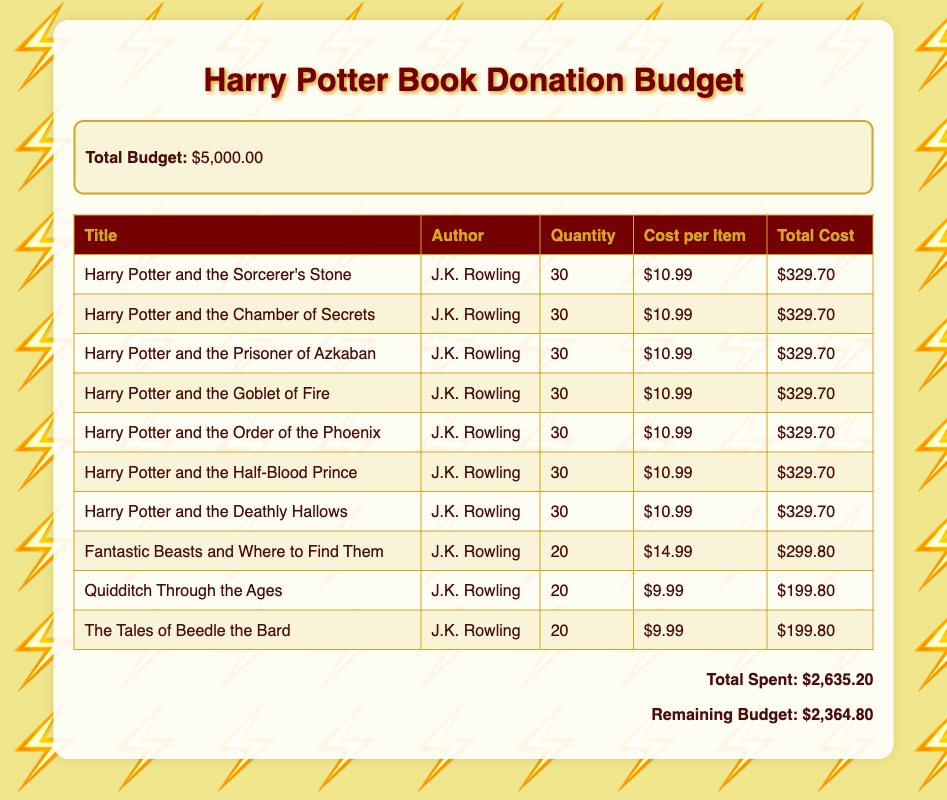What is the total budget? The total budget is stated at the top of the document as the initial amount allocated for the donations.
Answer: $5,000.00 How many copies of "Harry Potter and the Sorcerer's Stone" are being donated? The document lists the quantity of books for donation under the quantity column in the table.
Answer: 30 What is the cost per item for "Fantastic Beasts and Where to Find Them"? The price of each copy of the book is specified in the cost per item column of the table.
Answer: $14.99 What is the total cost for "Quidditch Through the Ages"? The total cost column gives the complete amount that would be spent on this specific title.
Answer: $199.80 How many titles have a quantity of 30? To answer this, count the titles listed in the quantity column that show a value of 30.
Answer: 7 What is the remaining budget after expenses? The remaining budget is calculated by subtracting the total spent from the total budget, shown at the bottom of the document.
Answer: $2,364.80 Who is the author of "The Tales of Beedle the Bard"? The author can be found in the table next to the title in the document.
Answer: J.K. Rowling Which book has the highest cost per item? This question requires reviewing the cost per item column to find the highest value among the listed books.
Answer: Fantastic Beasts and Where to Find Them How much was spent on "Harry Potter and the Chamber of Secrets"? The total cost column indicates the amount that will be spent on this particular book title.
Answer: $329.70 